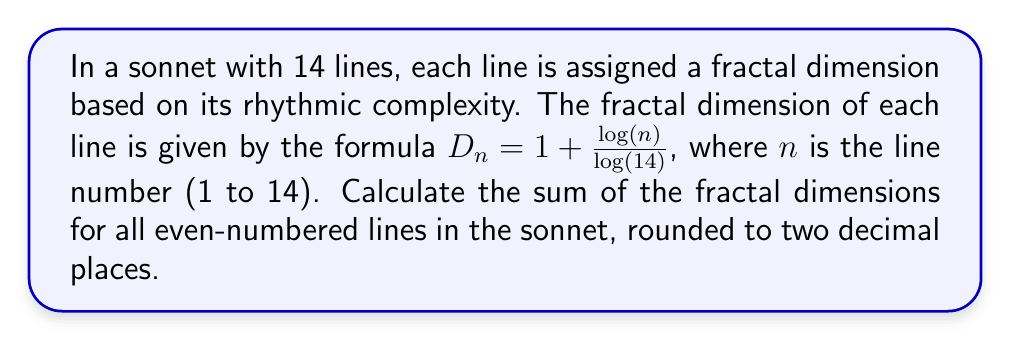Solve this math problem. Let's approach this step-by-step:

1) First, we need to identify the even-numbered lines: 2, 4, 6, 8, 10, 12, 14.

2) Now, let's calculate the fractal dimension for each of these lines using the given formula:

   For line 2: $D_2 = 1 + \frac{\log(2)}{\log(14)} = 1 + \frac{0.301}{1.146} \approx 1.263$
   
   For line 4: $D_4 = 1 + \frac{\log(4)}{\log(14)} = 1 + \frac{0.602}{1.146} \approx 1.525$
   
   For line 6: $D_6 = 1 + \frac{\log(6)}{\log(14)} = 1 + \frac{0.778}{1.146} \approx 1.679$
   
   For line 8: $D_8 = 1 + \frac{\log(8)}{\log(14)} = 1 + \frac{0.903}{1.146} \approx 1.788$
   
   For line 10: $D_{10} = 1 + \frac{\log(10)}{\log(14)} = 1 + \frac{1.000}{1.146} \approx 1.873$
   
   For line 12: $D_{12} = 1 + \frac{\log(12)}{\log(14)} = 1 + \frac{1.079}{1.146} \approx 1.942$
   
   For line 14: $D_{14} = 1 + \frac{\log(14)}{\log(14)} = 1 + \frac{1.146}{1.146} = 2.000$

3) Now, we sum these values:

   $1.263 + 1.525 + 1.679 + 1.788 + 1.873 + 1.942 + 2.000 = 12.070$

4) Rounding to two decimal places, we get 12.07.

This calculation reveals how the rhythmic complexity, as represented by the fractal dimension, increases throughout the sonnet, creating a mathematical representation of the poem's structure.
Answer: 12.07 